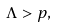Convert formula to latex. <formula><loc_0><loc_0><loc_500><loc_500>\Lambda > p ,</formula> 